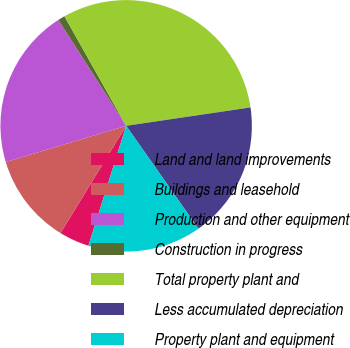Convert chart to OTSL. <chart><loc_0><loc_0><loc_500><loc_500><pie_chart><fcel>Land and land improvements<fcel>Buildings and leasehold<fcel>Production and other equipment<fcel>Construction in progress<fcel>Total property plant and<fcel>Less accumulated depreciation<fcel>Property plant and equipment<nl><fcel>3.89%<fcel>11.61%<fcel>20.59%<fcel>0.9%<fcel>30.83%<fcel>17.59%<fcel>14.6%<nl></chart> 